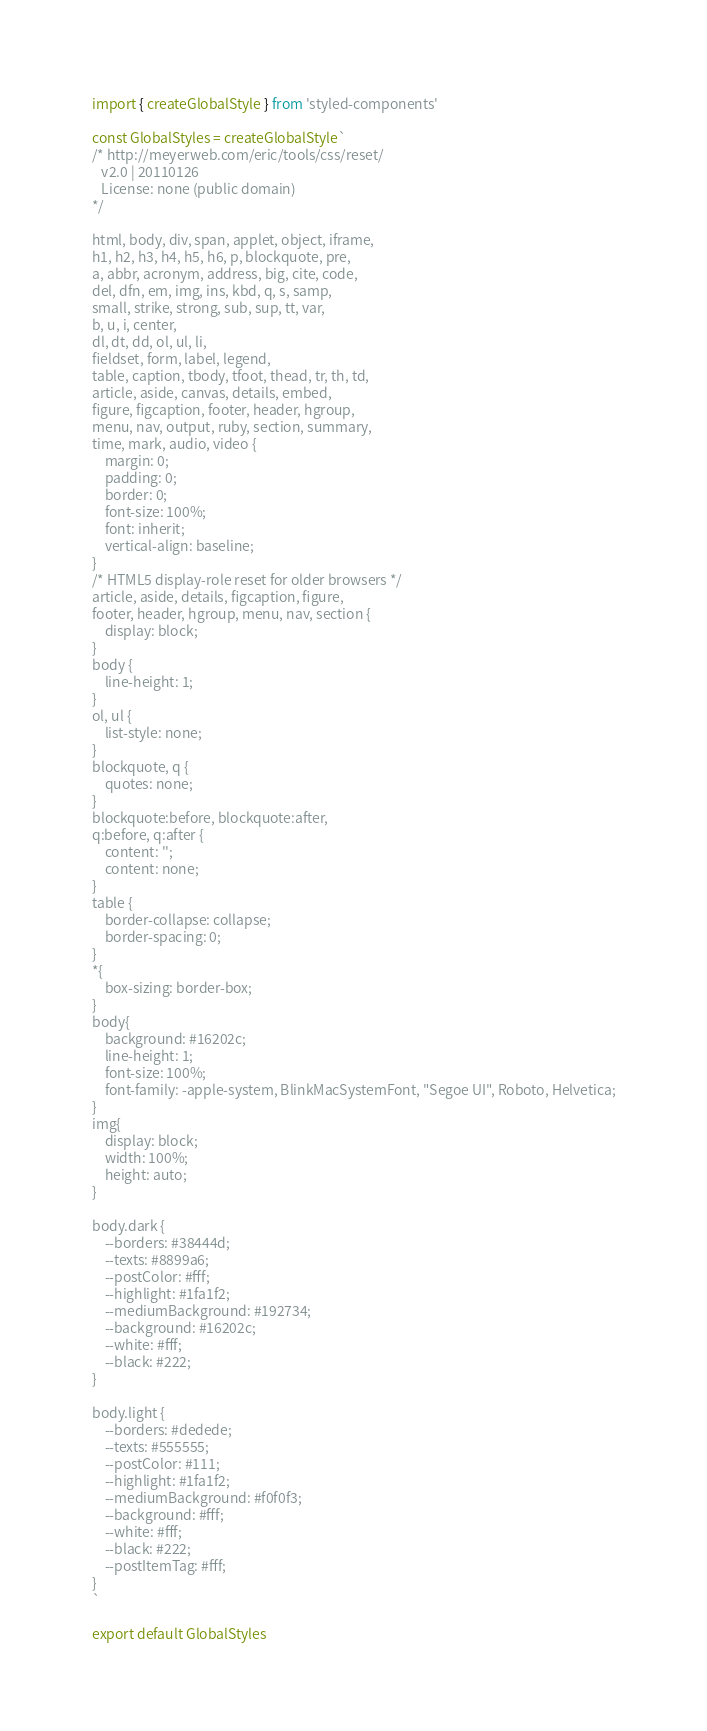<code> <loc_0><loc_0><loc_500><loc_500><_JavaScript_>import { createGlobalStyle } from 'styled-components'

const GlobalStyles = createGlobalStyle`
/* http://meyerweb.com/eric/tools/css/reset/ 
   v2.0 | 20110126
   License: none (public domain)
*/

html, body, div, span, applet, object, iframe,
h1, h2, h3, h4, h5, h6, p, blockquote, pre,
a, abbr, acronym, address, big, cite, code,
del, dfn, em, img, ins, kbd, q, s, samp,
small, strike, strong, sub, sup, tt, var,
b, u, i, center,
dl, dt, dd, ol, ul, li,
fieldset, form, label, legend,
table, caption, tbody, tfoot, thead, tr, th, td,
article, aside, canvas, details, embed, 
figure, figcaption, footer, header, hgroup, 
menu, nav, output, ruby, section, summary,
time, mark, audio, video {
	margin: 0;
	padding: 0;
	border: 0;
	font-size: 100%;
	font: inherit;
	vertical-align: baseline;
}
/* HTML5 display-role reset for older browsers */
article, aside, details, figcaption, figure, 
footer, header, hgroup, menu, nav, section {
	display: block;
}
body {
	line-height: 1;
}
ol, ul {
	list-style: none;
}
blockquote, q {
	quotes: none;
}
blockquote:before, blockquote:after,
q:before, q:after {
	content: '';
	content: none;
}
table {
	border-collapse: collapse;
	border-spacing: 0;
}
*{
    box-sizing: border-box;
}
body{
    background: #16202c;
    line-height: 1;
    font-size: 100%;
    font-family: -apple-system, BlinkMacSystemFont, "Segoe UI", Roboto, Helvetica;
}
img{
    display: block;
    width: 100%;
    height: auto;
}

body.dark {
	--borders: #38444d;
	--texts: #8899a6;
	--postColor: #fff;
	--highlight: #1fa1f2;
	--mediumBackground: #192734;
	--background: #16202c;
	--white: #fff;
	--black: #222;
}

body.light {
	--borders: #dedede;
	--texts: #555555;
	--postColor: #111;
	--highlight: #1fa1f2;
	--mediumBackground: #f0f0f3;
	--background: #fff;
	--white: #fff;
	--black: #222;
	--postItemTag: #fff;
}
`

export default GlobalStyles</code> 